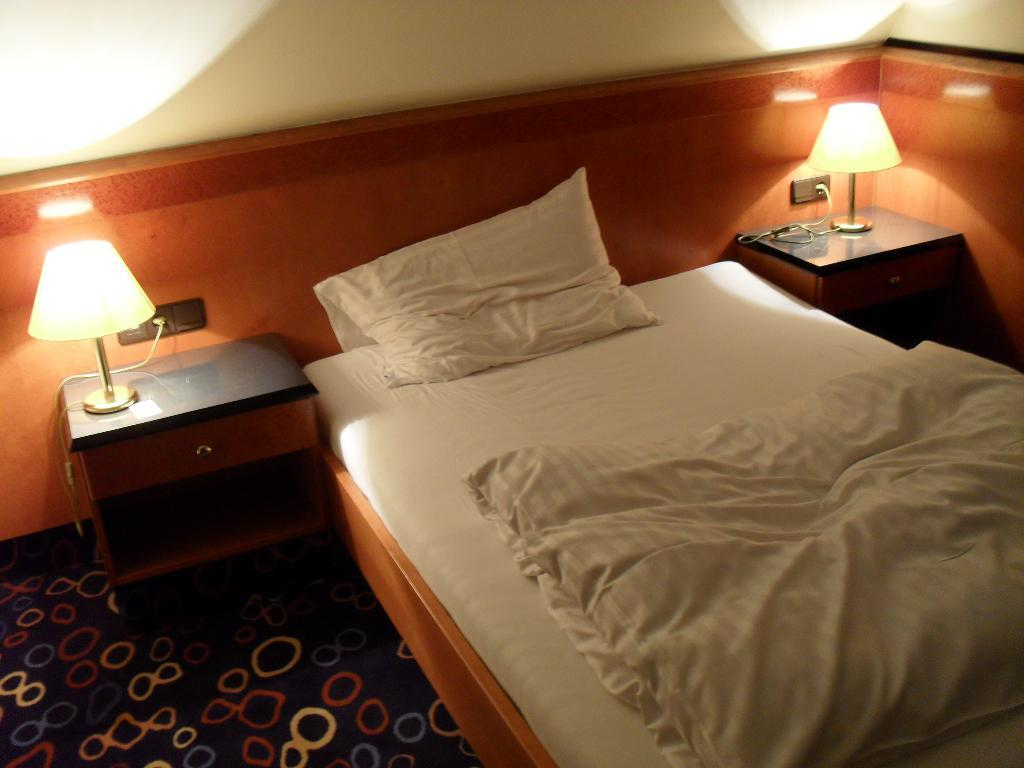What piece of furniture is the main subject of the image? There is a bed in the image. What is placed on the bed? There is a pillow and a blanket on the bed. What is located beside the bed? There is a table beside the bed. What object is on the table beside the bed? There is a lamp on the table beside the bed. How much rice is visible on the bed in the image? There is no rice present in the image. What day of the week is depicted in the image? The image does not depict a specific day of the week. 